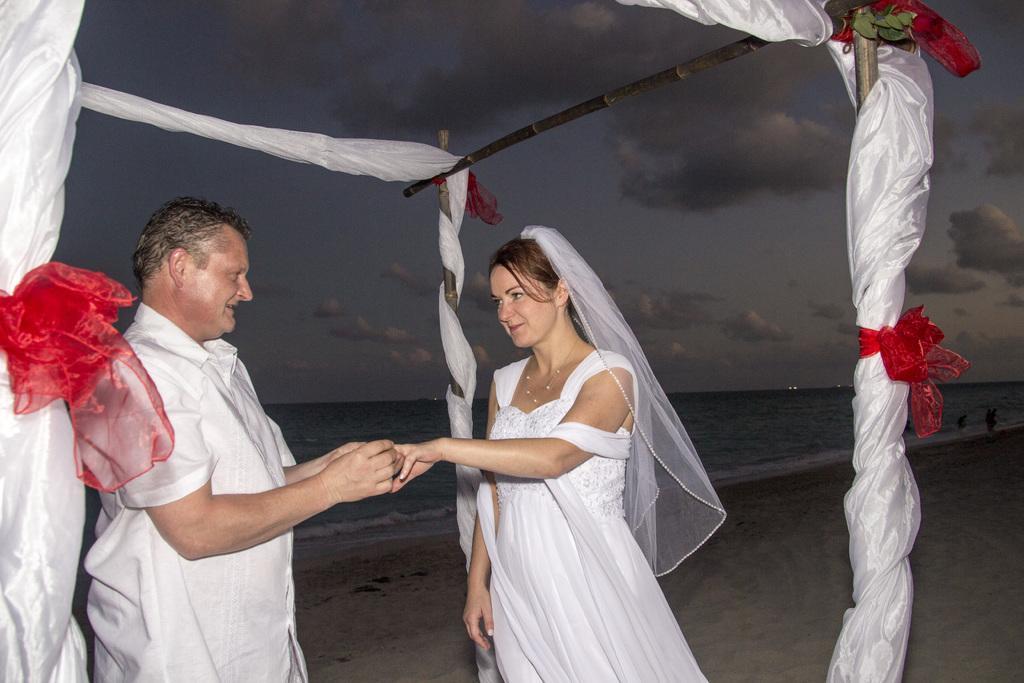Describe this image in one or two sentences. In the center of the image there are two persons wearing white color dress. To the left side of the image there is a white color cloth. There are sticks. In the background of the image there is sky and water. At the bottom of the image there is sand. 